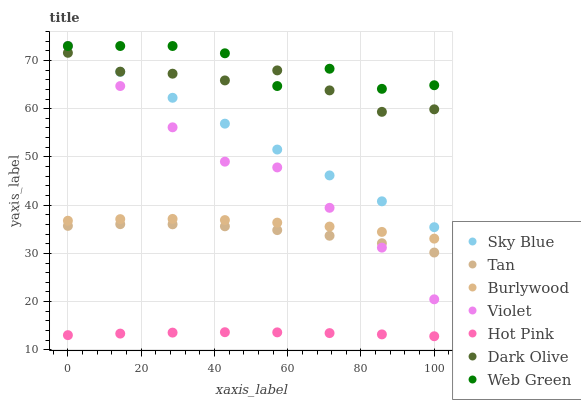Does Hot Pink have the minimum area under the curve?
Answer yes or no. Yes. Does Web Green have the maximum area under the curve?
Answer yes or no. Yes. Does Burlywood have the minimum area under the curve?
Answer yes or no. No. Does Burlywood have the maximum area under the curve?
Answer yes or no. No. Is Sky Blue the smoothest?
Answer yes or no. Yes. Is Web Green the roughest?
Answer yes or no. Yes. Is Burlywood the smoothest?
Answer yes or no. No. Is Burlywood the roughest?
Answer yes or no. No. Does Hot Pink have the lowest value?
Answer yes or no. Yes. Does Burlywood have the lowest value?
Answer yes or no. No. Does Sky Blue have the highest value?
Answer yes or no. Yes. Does Burlywood have the highest value?
Answer yes or no. No. Is Tan less than Web Green?
Answer yes or no. Yes. Is Dark Olive greater than Burlywood?
Answer yes or no. Yes. Does Web Green intersect Sky Blue?
Answer yes or no. Yes. Is Web Green less than Sky Blue?
Answer yes or no. No. Is Web Green greater than Sky Blue?
Answer yes or no. No. Does Tan intersect Web Green?
Answer yes or no. No. 